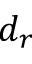Convert formula to latex. <formula><loc_0><loc_0><loc_500><loc_500>d _ { r }</formula> 